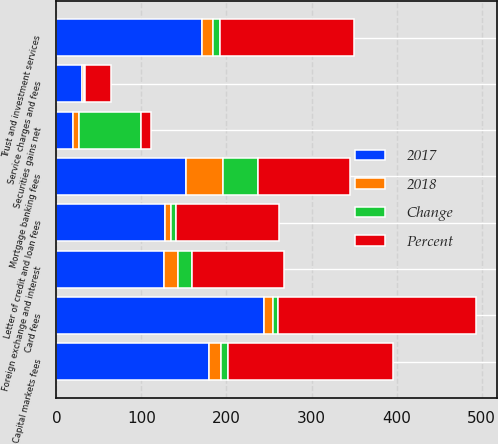Convert chart to OTSL. <chart><loc_0><loc_0><loc_500><loc_500><stacked_bar_chart><ecel><fcel>Service charges and fees<fcel>Card fees<fcel>Capital markets fees<fcel>Trust and investment services<fcel>Mortgage banking fees<fcel>Letter of credit and loan fees<fcel>Foreign exchange and interest<fcel>Securities gains net<nl><fcel>2017<fcel>30<fcel>244<fcel>179<fcel>171<fcel>152<fcel>128<fcel>126<fcel>19<nl><fcel>Percent<fcel>30<fcel>233<fcel>194<fcel>158<fcel>108<fcel>121<fcel>109<fcel>11<nl><fcel>2018<fcel>3<fcel>11<fcel>15<fcel>13<fcel>44<fcel>7<fcel>17<fcel>8<nl><fcel>Change<fcel>1<fcel>5<fcel>8<fcel>8<fcel>41<fcel>6<fcel>16<fcel>73<nl></chart> 